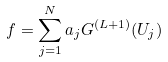Convert formula to latex. <formula><loc_0><loc_0><loc_500><loc_500>f = \sum _ { j = 1 } ^ { N } a _ { j } G ^ { ( L + 1 ) } ( U _ { j } )</formula> 